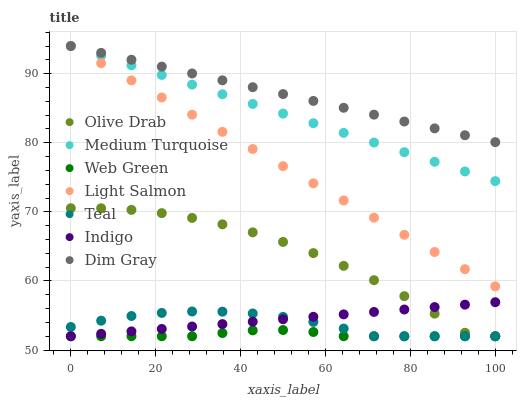Does Web Green have the minimum area under the curve?
Answer yes or no. Yes. Does Dim Gray have the maximum area under the curve?
Answer yes or no. Yes. Does Indigo have the minimum area under the curve?
Answer yes or no. No. Does Indigo have the maximum area under the curve?
Answer yes or no. No. Is Indigo the smoothest?
Answer yes or no. Yes. Is Olive Drab the roughest?
Answer yes or no. Yes. Is Dim Gray the smoothest?
Answer yes or no. No. Is Dim Gray the roughest?
Answer yes or no. No. Does Indigo have the lowest value?
Answer yes or no. Yes. Does Dim Gray have the lowest value?
Answer yes or no. No. Does Medium Turquoise have the highest value?
Answer yes or no. Yes. Does Indigo have the highest value?
Answer yes or no. No. Is Teal less than Medium Turquoise?
Answer yes or no. Yes. Is Medium Turquoise greater than Web Green?
Answer yes or no. Yes. Does Medium Turquoise intersect Light Salmon?
Answer yes or no. Yes. Is Medium Turquoise less than Light Salmon?
Answer yes or no. No. Is Medium Turquoise greater than Light Salmon?
Answer yes or no. No. Does Teal intersect Medium Turquoise?
Answer yes or no. No. 